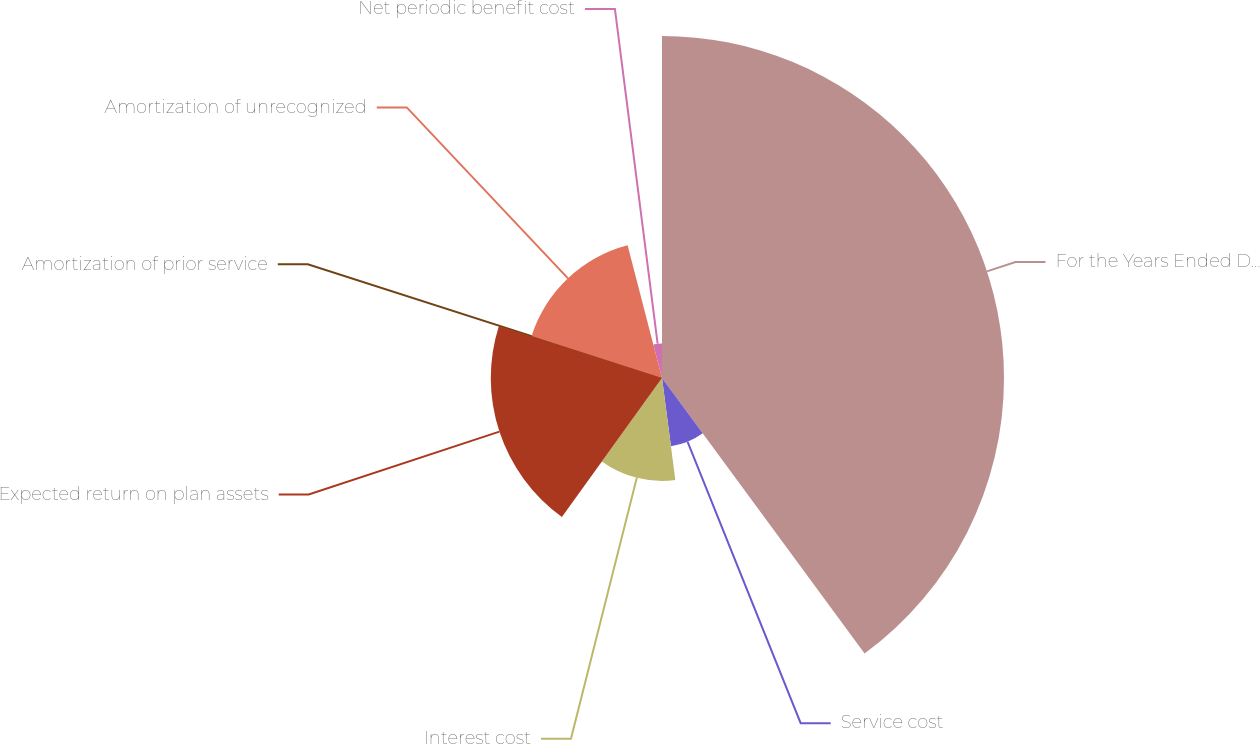<chart> <loc_0><loc_0><loc_500><loc_500><pie_chart><fcel>For the Years Ended December<fcel>Service cost<fcel>Interest cost<fcel>Expected return on plan assets<fcel>Amortization of prior service<fcel>Amortization of unrecognized<fcel>Net periodic benefit cost<nl><fcel>39.91%<fcel>8.02%<fcel>12.01%<fcel>19.98%<fcel>0.05%<fcel>15.99%<fcel>4.04%<nl></chart> 